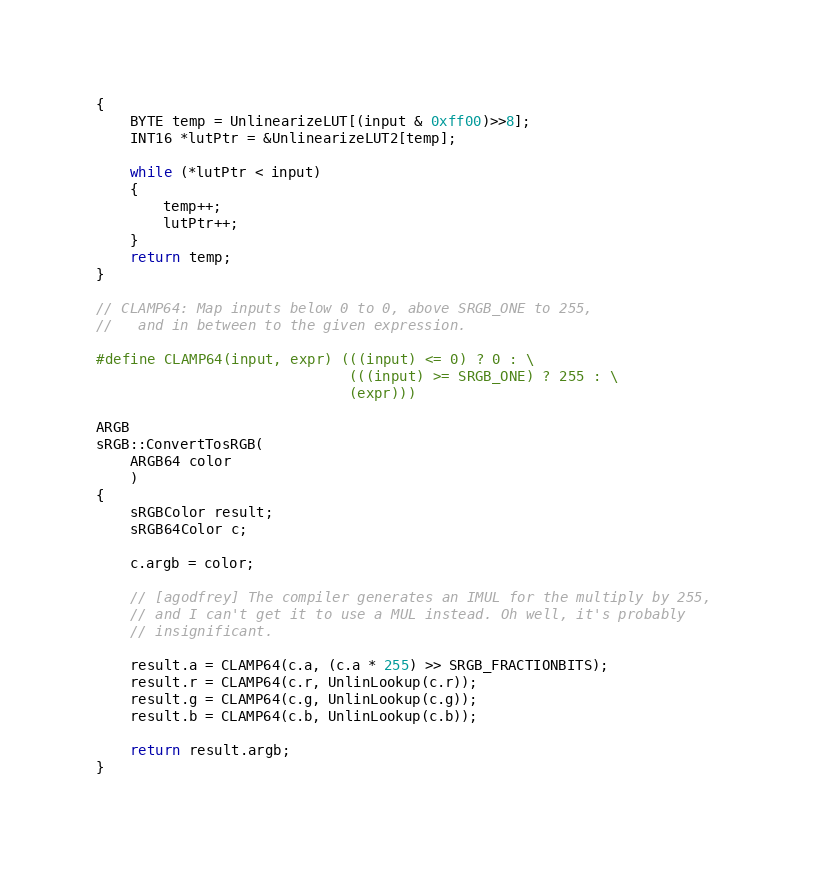Convert code to text. <code><loc_0><loc_0><loc_500><loc_500><_C++_>{
    BYTE temp = UnlinearizeLUT[(input & 0xff00)>>8];
    INT16 *lutPtr = &UnlinearizeLUT2[temp];
    
    while (*lutPtr < input) 
    {
        temp++;
        lutPtr++;
    }
    return temp;
}

// CLAMP64: Map inputs below 0 to 0, above SRGB_ONE to 255,
//   and in between to the given expression.

#define CLAMP64(input, expr) (((input) <= 0) ? 0 : \
                              (((input) >= SRGB_ONE) ? 255 : \
                              (expr)))

ARGB
sRGB::ConvertTosRGB(
    ARGB64 color
    ) 
{
    sRGBColor result;
    sRGB64Color c;
    
    c.argb = color;
    
    // [agodfrey] The compiler generates an IMUL for the multiply by 255, 
    // and I can't get it to use a MUL instead. Oh well, it's probably
    // insignificant.
    
    result.a = CLAMP64(c.a, (c.a * 255) >> SRGB_FRACTIONBITS);
    result.r = CLAMP64(c.r, UnlinLookup(c.r));
    result.g = CLAMP64(c.g, UnlinLookup(c.g));
    result.b = CLAMP64(c.b, UnlinLookup(c.b));
    
    return result.argb;
}

</code> 